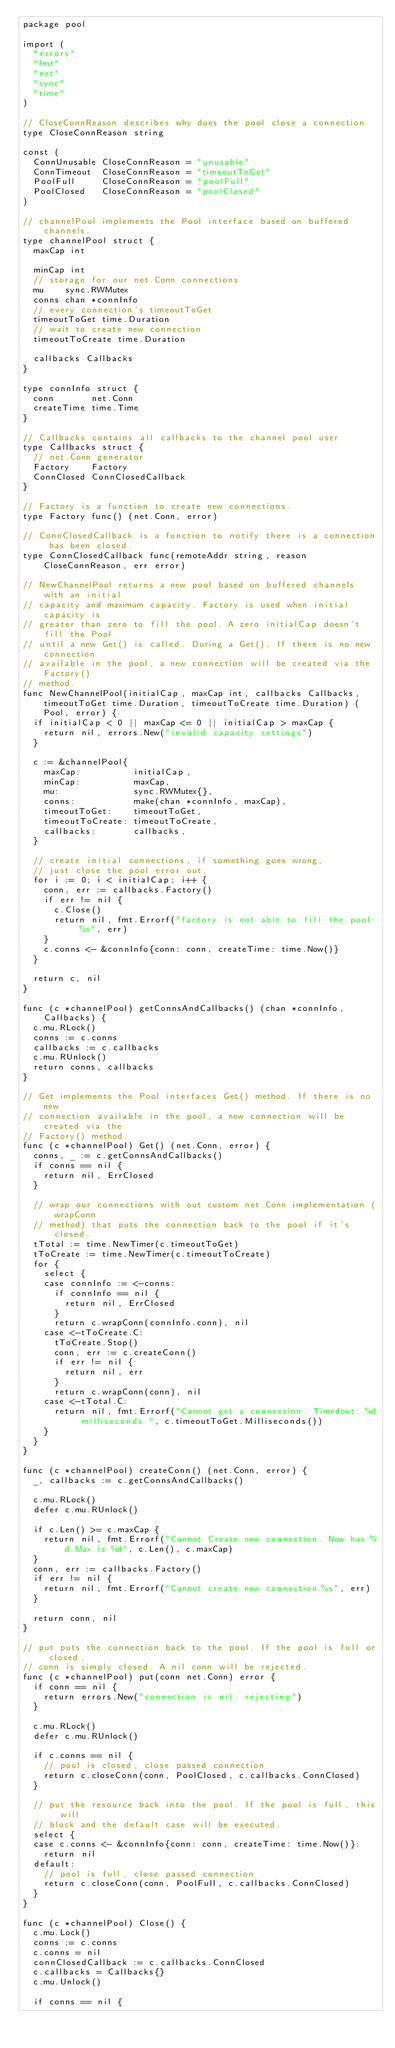Convert code to text. <code><loc_0><loc_0><loc_500><loc_500><_Go_>package pool

import (
	"errors"
	"fmt"
	"net"
	"sync"
	"time"
)

// CloseConnReason describes why does the pool close a connection
type CloseConnReason string

const (
	ConnUnusable CloseConnReason = "unusable"
	ConnTimeout  CloseConnReason = "timeoutToGet"
	PoolFull     CloseConnReason = "poolFull"
	PoolClosed   CloseConnReason = "poolClosed"
)

// channelPool implements the Pool interface based on buffered channels.
type channelPool struct {
	maxCap int

	minCap int
	// storage for our net.Conn connections
	mu    sync.RWMutex
	conns chan *connInfo
	// every connection's timeoutToGet
	timeoutToGet time.Duration
	// wait to create new connection
	timeoutToCreate time.Duration

	callbacks Callbacks
}

type connInfo struct {
	conn       net.Conn
	createTime time.Time
}

// Callbacks contains all callbacks to the channel pool user
type Callbacks struct {
	// net.Conn generator
	Factory    Factory
	ConnClosed ConnClosedCallback
}

// Factory is a function to create new connections.
type Factory func() (net.Conn, error)

// ConnClosedCallback is a function to notify there is a connection has been closed.
type ConnClosedCallback func(remoteAddr string, reason CloseConnReason, err error)

// NewChannelPool returns a new pool based on buffered channels with an initial
// capacity and maximum capacity. Factory is used when initial capacity is
// greater than zero to fill the pool. A zero initialCap doesn't fill the Pool
// until a new Get() is called. During a Get(), If there is no new connection
// available in the pool, a new connection will be created via the Factory()
// method.
func NewChannelPool(initialCap, maxCap int, callbacks Callbacks, timeoutToGet time.Duration, timeoutToCreate time.Duration) (Pool, error) {
	if initialCap < 0 || maxCap <= 0 || initialCap > maxCap {
		return nil, errors.New("invalid capacity settings")
	}

	c := &channelPool{
		maxCap:          initialCap,
		minCap:          maxCap,
		mu:              sync.RWMutex{},
		conns:           make(chan *connInfo, maxCap),
		timeoutToGet:    timeoutToGet,
		timeoutToCreate: timeoutToCreate,
		callbacks:       callbacks,
	}

	// create initial connections, if something goes wrong,
	// just close the pool error out.
	for i := 0; i < initialCap; i++ {
		conn, err := callbacks.Factory()
		if err != nil {
			c.Close()
			return nil, fmt.Errorf("factory is not able to fill the pool: %s", err)
		}
		c.conns <- &connInfo{conn: conn, createTime: time.Now()}
	}

	return c, nil
}

func (c *channelPool) getConnsAndCallbacks() (chan *connInfo, Callbacks) {
	c.mu.RLock()
	conns := c.conns
	callbacks := c.callbacks
	c.mu.RUnlock()
	return conns, callbacks
}

// Get implements the Pool interfaces Get() method. If there is no new
// connection available in the pool, a new connection will be created via the
// Factory() method.
func (c *channelPool) Get() (net.Conn, error) {
	conns, _ := c.getConnsAndCallbacks()
	if conns == nil {
		return nil, ErrClosed
	}

	// wrap our connections with out custom net.Conn implementation (wrapConn
	// method) that puts the connection back to the pool if it's closed.
	tTotal := time.NewTimer(c.timeoutToGet)
	tToCreate := time.NewTimer(c.timeoutToCreate)
	for {
		select {
		case connInfo := <-conns:
			if connInfo == nil {
				return nil, ErrClosed
			}
			return c.wrapConn(connInfo.conn), nil
		case <-tToCreate.C:
			tToCreate.Stop()
			conn, err := c.createConn()
			if err != nil {
				return nil, err
			}
			return c.wrapConn(conn), nil
		case <-tTotal.C:
			return nil, fmt.Errorf("Cannot get a connection. Timedout: %d milliseconds ", c.timeoutToGet.Milliseconds())
		}
	}
}

func (c *channelPool) createConn() (net.Conn, error) {
	_, callbacks := c.getConnsAndCallbacks()

	c.mu.RLock()
	defer c.mu.RUnlock()

	if c.Len() >= c.maxCap {
		return nil, fmt.Errorf("Connot Create new connection. Now has %d.Max is %d", c.Len(), c.maxCap)
	}
	conn, err := callbacks.Factory()
	if err != nil {
		return nil, fmt.Errorf("Cannot create new connection.%s", err)
	}

	return conn, nil
}

// put puts the connection back to the pool. If the pool is full or closed,
// conn is simply closed. A nil conn will be rejected.
func (c *channelPool) put(conn net.Conn) error {
	if conn == nil {
		return errors.New("connection is nil. rejecting")
	}

	c.mu.RLock()
	defer c.mu.RUnlock()

	if c.conns == nil {
		// pool is closed, close passed connection
		return c.closeConn(conn, PoolClosed, c.callbacks.ConnClosed)
	}

	// put the resource back into the pool. If the pool is full, this will
	// block and the default case will be executed.
	select {
	case c.conns <- &connInfo{conn: conn, createTime: time.Now()}:
		return nil
	default:
		// pool is full, close passed connection
		return c.closeConn(conn, PoolFull, c.callbacks.ConnClosed)
	}
}

func (c *channelPool) Close() {
	c.mu.Lock()
	conns := c.conns
	c.conns = nil
	connClosedCallback := c.callbacks.ConnClosed
	c.callbacks = Callbacks{}
	c.mu.Unlock()

	if conns == nil {</code> 